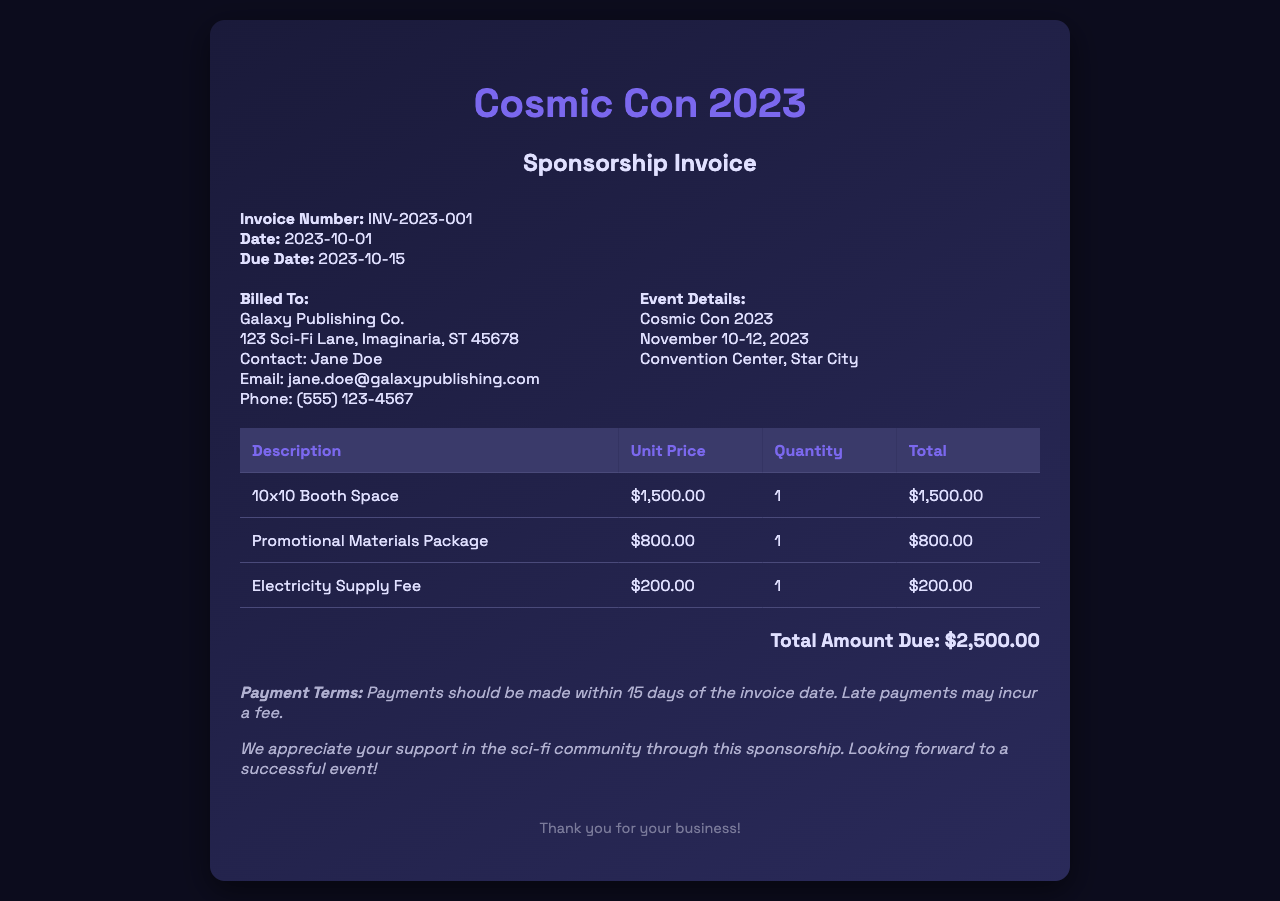What is the invoice number? The invoice number is stated in the invoice details section.
Answer: INV-2023-001 When is the due date for the invoice? The due date is mentioned alongside the invoice date in the invoice details section.
Answer: 2023-10-15 How much is the unit price for the 10x10 Booth Space? The unit price for the booth space is listed in the table under the unit price column.
Answer: $1,500.00 What is the total amount due? The total amount due is highlighted at the bottom of the invoice.
Answer: $2,500.00 What is included in the promotional materials package? The specific contents of the promotional materials package are not detailed within the invoice, but it is a stated item under the table.
Answer: Promotional Materials Package (details not specified) Who is the contact person at Galaxy Publishing Co.? The contact person is mentioned in the billing info section of the invoice.
Answer: Jane Doe What is the electricity supply fee? The electricity supply fee is listed directly in the table along with other charges.
Answer: $200.00 What are the payment terms mentioned in the invoice? The payment terms are described in the notes section at the end of the invoice.
Answer: Payments should be made within 15 days of the invoice date 